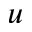<formula> <loc_0><loc_0><loc_500><loc_500>u</formula> 